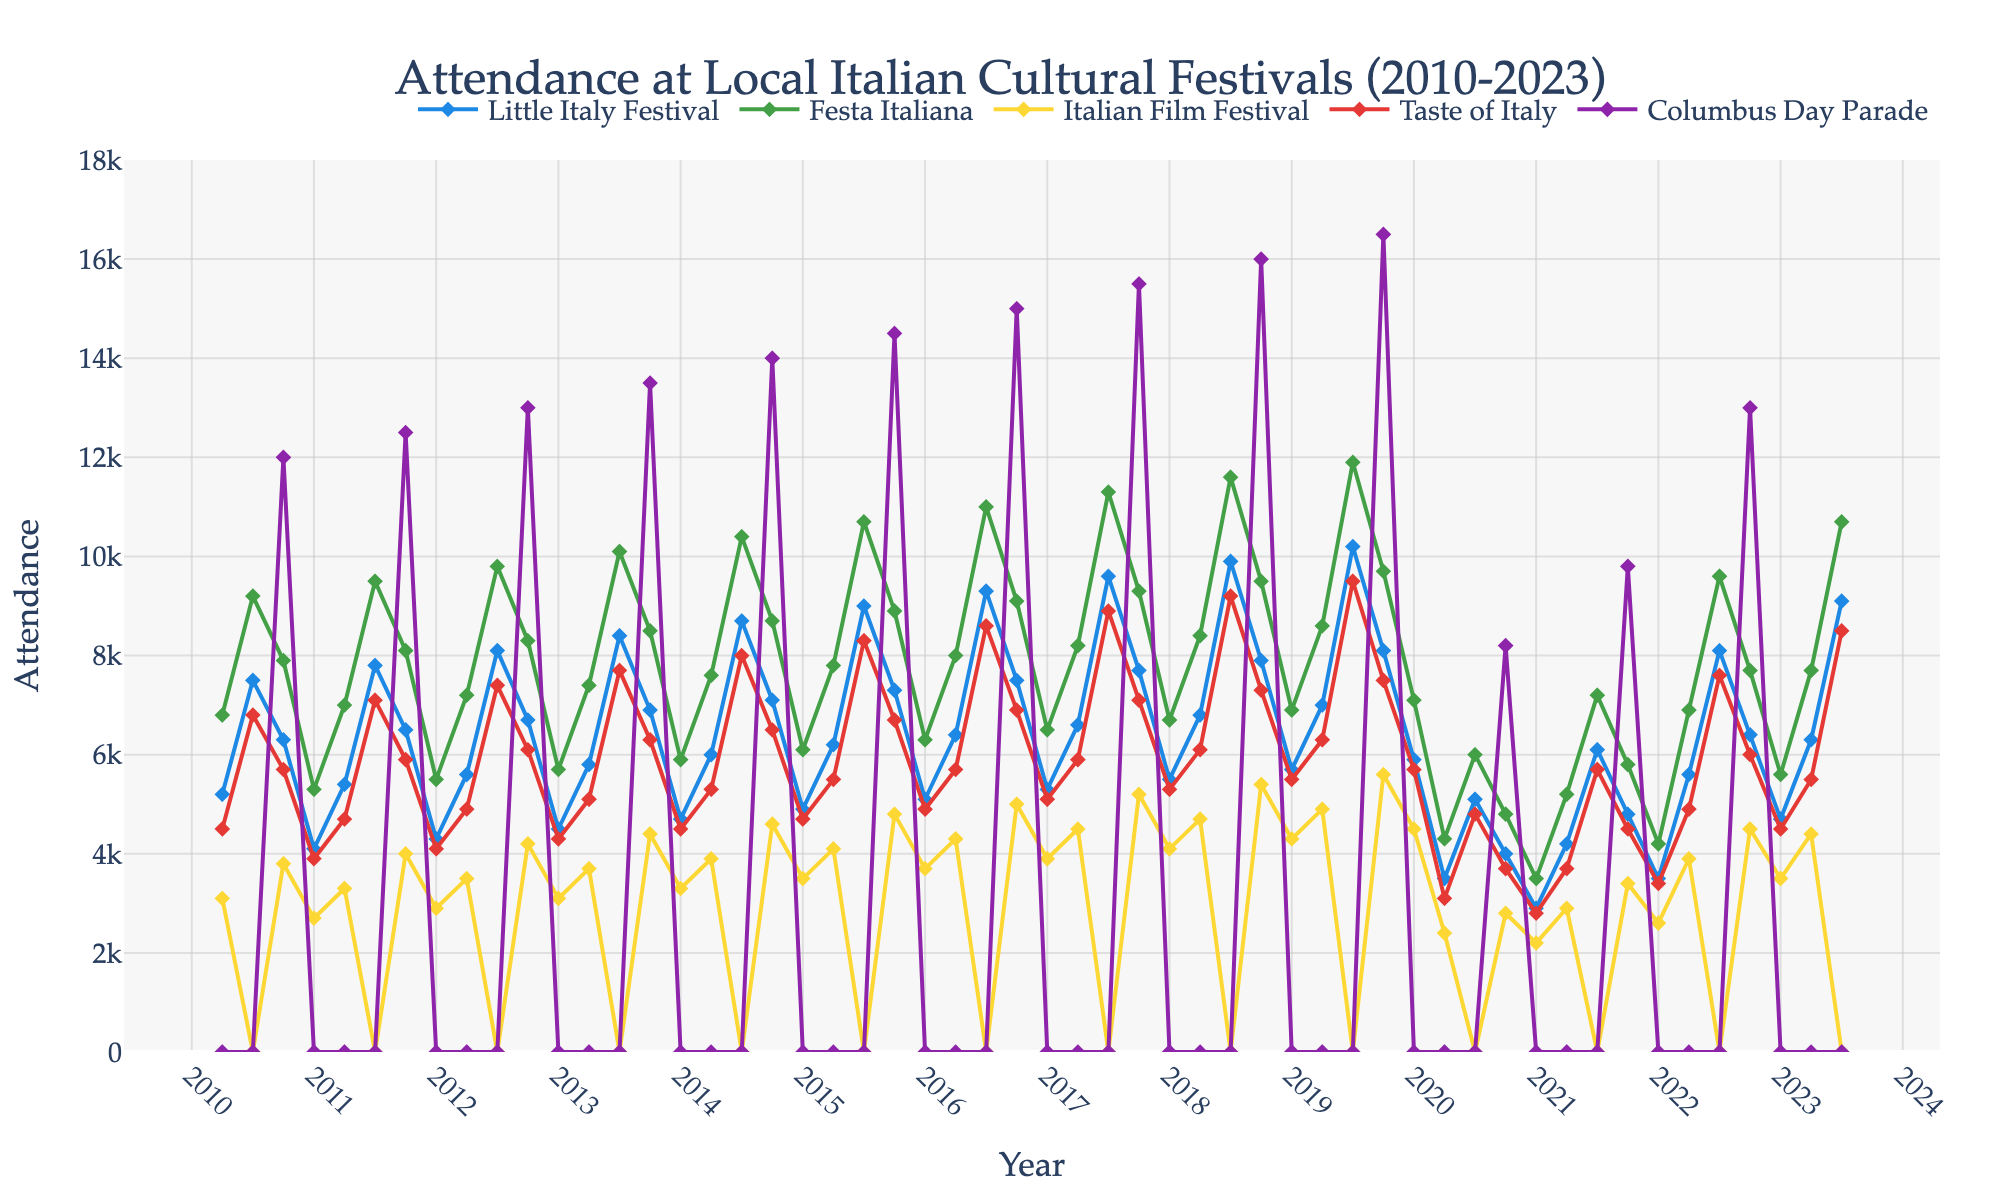Which festival has the highest peak attendance during the entire period? By examining the highest points in the lines for each festival, the Columbus Day Parade has the highest peak attendance in Fall 2019, reaching 16500.
Answer: Columbus Day Parade Which season shows the lowest attendance in 2020 for all festivals? Checking the data points for each festival in 2020, the Winter season has the lowest attendance across all festivals with significantly lower values for each festival.
Answer: Winter Between which years did the Little Italy Festival show the most significant increase in attendance from Spring to Summer? For the Little Italy Festival, the most significant increase in attendance from Spring to Summer was observed between 2010 and 2013. However, between Summer 2019 (10200) and Summer 2020 (5100), there was a large decrease, signifying a contrasting trend. To see the most significant increase: Comparing Spring to Summer for each year, we observe the most significant rise from Spring (4200) to Summer (7800) in 2018.
Answer: 2018 Calculate the average attendance for Festa Italiana in the summer seasons from 2010 to 2023. Sum the attendance values for Festa Italiana during summer: (9200 + 9500 + 9800 + 10100 + 10400 + 10700 + 11000 + 11300 + 11600 + 11900 + 6000 + 7200 + 9600 + 10700) and then divide by the count (14): (9200+9500+9800+10100+10400+10700+11000+11300+11600+11900+6000+7200+9600+10700) / 14 = 9860.
Answer: 9860 Which festival consistently shows zero attendance in the Summer season from 2010 to 2023? Observing the graph, the Italian Film Festival shows zero attendance consistently during the Summer seasons from 2010 to 2023.
Answer: Italian Film Festival 